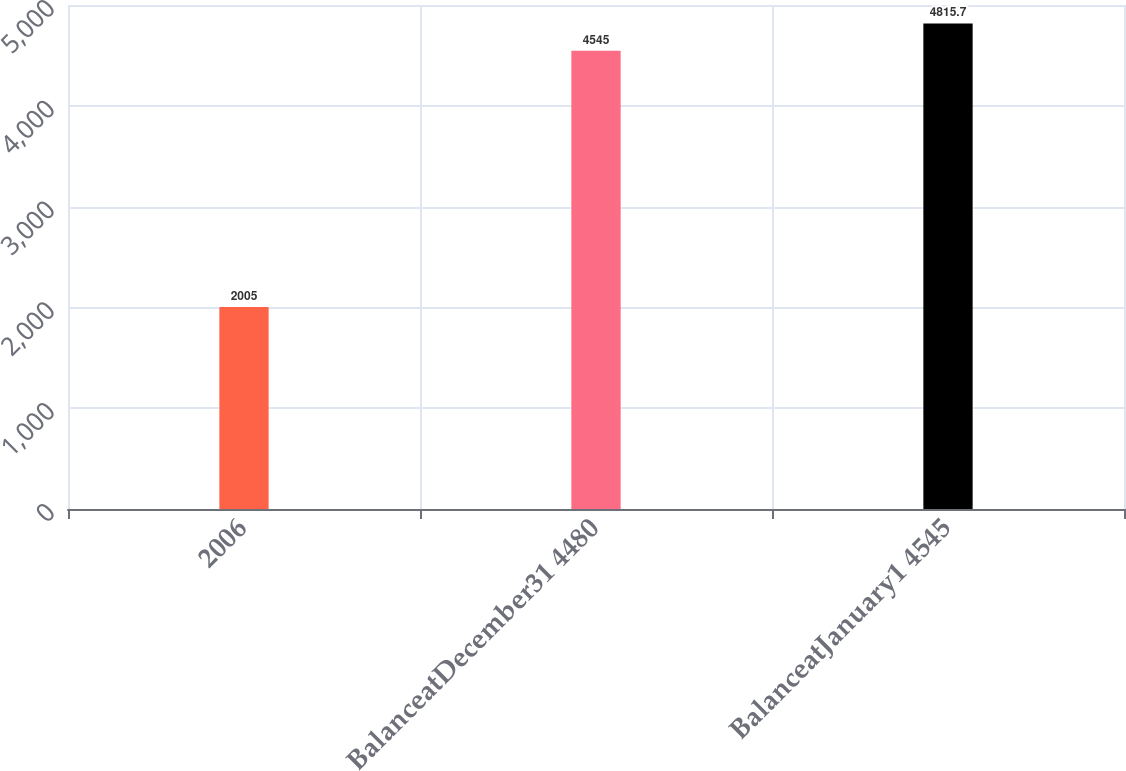<chart> <loc_0><loc_0><loc_500><loc_500><bar_chart><fcel>2006<fcel>BalanceatDecember31 4480<fcel>BalanceatJanuary1 4545<nl><fcel>2005<fcel>4545<fcel>4815.7<nl></chart> 